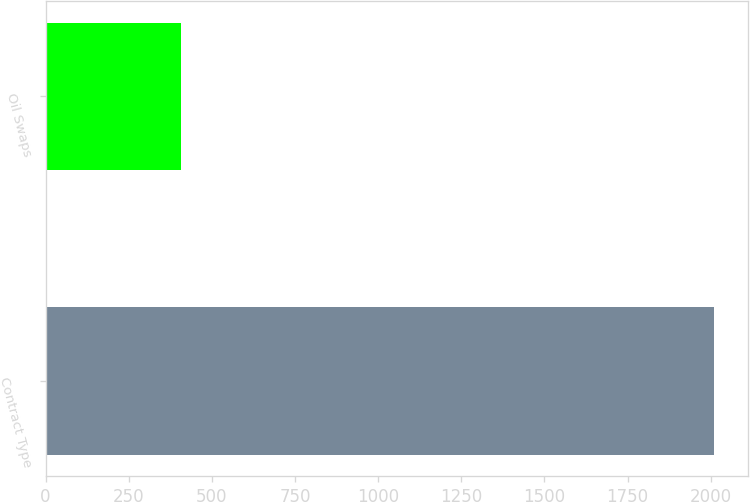Convert chart. <chart><loc_0><loc_0><loc_500><loc_500><bar_chart><fcel>Contract Type<fcel>Oil Swaps<nl><fcel>2011<fcel>408<nl></chart> 